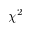<formula> <loc_0><loc_0><loc_500><loc_500>\chi ^ { 2 }</formula> 